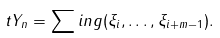<formula> <loc_0><loc_0><loc_500><loc_500>\ t Y _ { n } = \sum i n g ( \xi _ { i } , \dots , \xi _ { i + m - 1 } ) .</formula> 